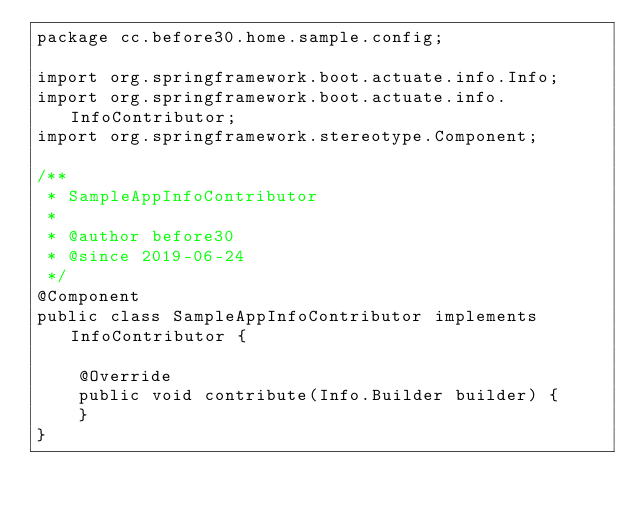Convert code to text. <code><loc_0><loc_0><loc_500><loc_500><_Java_>package cc.before30.home.sample.config;

import org.springframework.boot.actuate.info.Info;
import org.springframework.boot.actuate.info.InfoContributor;
import org.springframework.stereotype.Component;

/**
 * SampleAppInfoContributor
 *
 * @author before30
 * @since 2019-06-24
 */
@Component
public class SampleAppInfoContributor implements InfoContributor {

    @Override
    public void contribute(Info.Builder builder) {
    }
}
</code> 